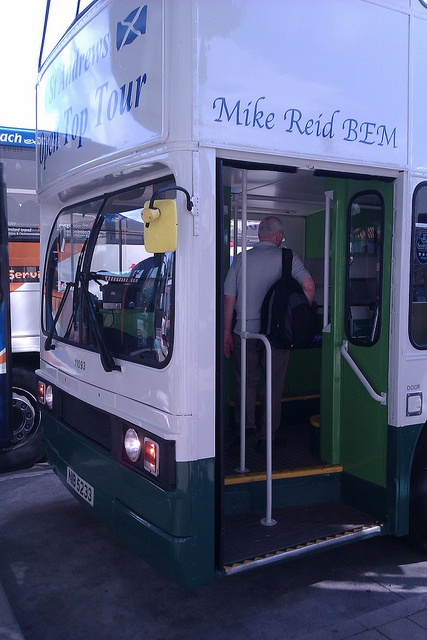Describe the objects in this image and their specific colors. I can see bus in black, white, lavender, gray, and navy tones, bus in white, black, gray, and lavender tones, people in white, black, purple, navy, and gray tones, and backpack in white, black, navy, purple, and gray tones in this image. 